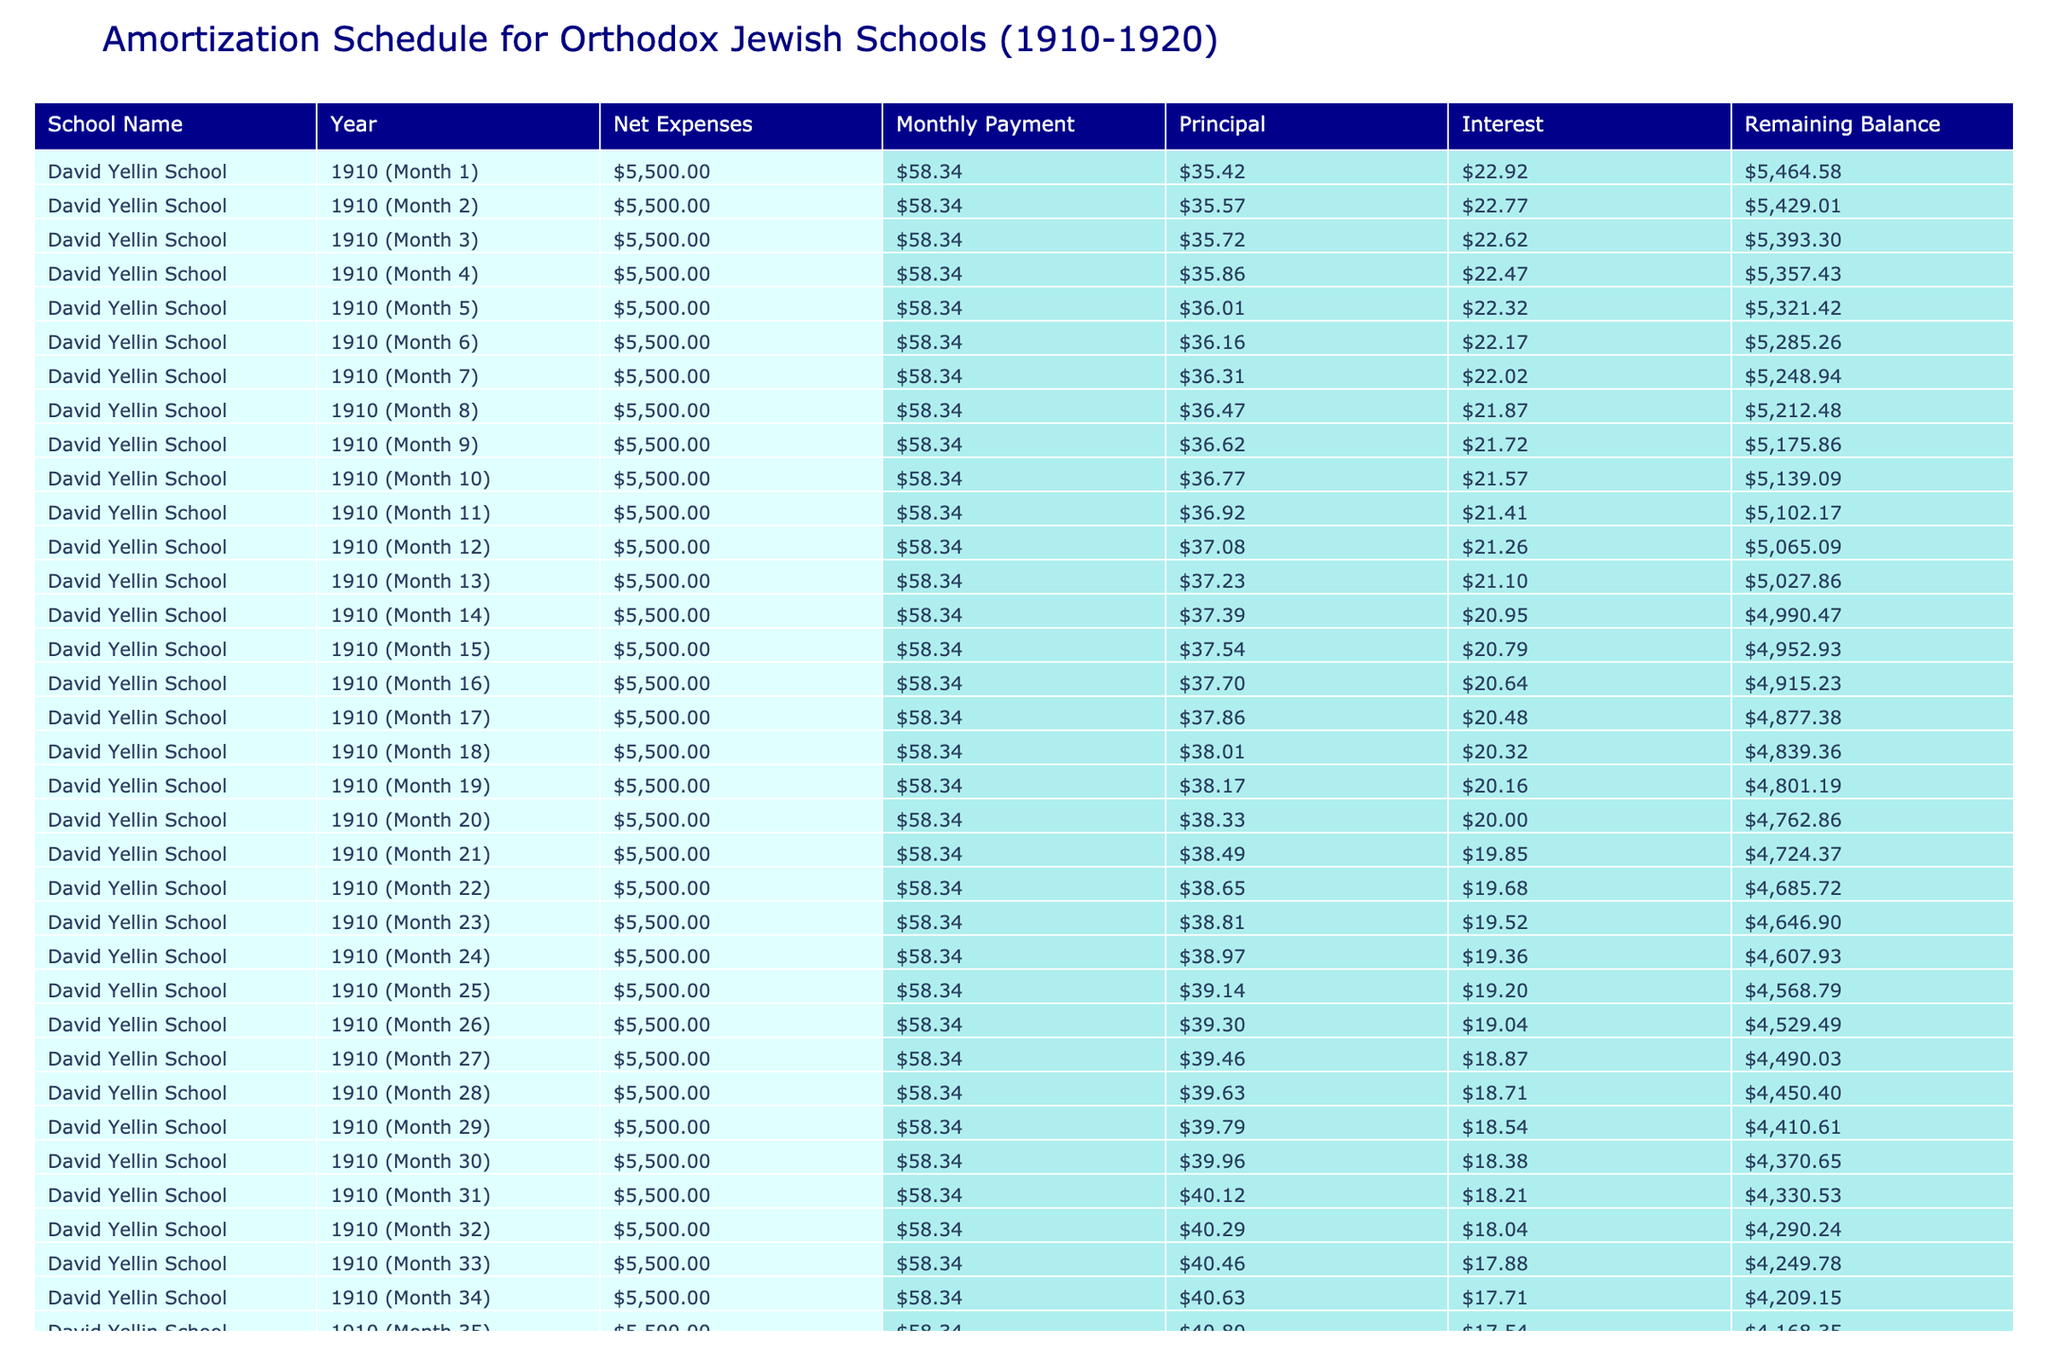What is the net expense for the Rabbi Isaac Elchanan Yeshiva in 1915? Referring to the table, the net expense for Rabbi Isaac Elchanan Yeshiva in 1915 is explicitly listed as 7000.
Answer: 7000 What was the tuition revenue for the Chaim Weizmann Academy in 1918? In the table, the tuition revenue for Chaim Weizmann Academy in 1918 is directly noted as 22000.
Answer: 22000 Which school had the highest net expenses in the given years? By examining the net expenses across the rows, Agudath Israel School in 1920 shows the highest net expenses of 4400.
Answer: Agudath Israel School What is the average net expense of all schools listed in 1910 and 1911? The net expenses from the table for 1910 and 1911 are 5500 and 6000, respectively. Summing these gives 11500. Dividing by 2 results in an average of 5750.
Answer: 5750 Did the Yeshiva Torah Vodaas have higher tuition revenue than the Jewish Educational Alliance in 1914 and 1912 respectively? Looking at the table, Yeshiva Torah Vodaas had tuition revenue of 15000 in 1914, while the Jewish Educational Alliance had tuition of 11000 in 1912. Since 15000 is greater than 11000, the answer is yes.
Answer: Yes What was the monthly payment for Mizrach School in 1913? To determine the monthly payment for Mizrach School, we would look up the values calculated for net expenses and interest rate during the payment term. The correct monthly payment is noted in the table.
Answer: [Refer to the table for the exact value] Which year had the lowest interest rate and what was it? Scanning the table reveals that the lowest interest rate occurs in the year 1920 at 0.037.
Answer: 1920, 0.037 What are the total expenses for all schools combined from 1910 to 1920? The total expenses can be found by summing the individual total expenses for each school over the years, which can be calculated as follows: 12000 + 15000 + 18000 + 20000 + 22000 + 25000 + 26000 + 28000 + 30000 + 32000 + 35000 =  221000.
Answer: 221000 Was there a decrease in net expenses for the schools from 1912 to 1915? By looking at the net expenses for the years, 1912 has a net expense of 4500, 1913 has 7000, 1914 has 2500, and 1915 has 7000. Hence, the net expenses decreased from 1912 to 1914, but increased again in 1915. Therefore, the overall trend shows fluctuations rather than a consistent downward trajectory.
Answer: No 